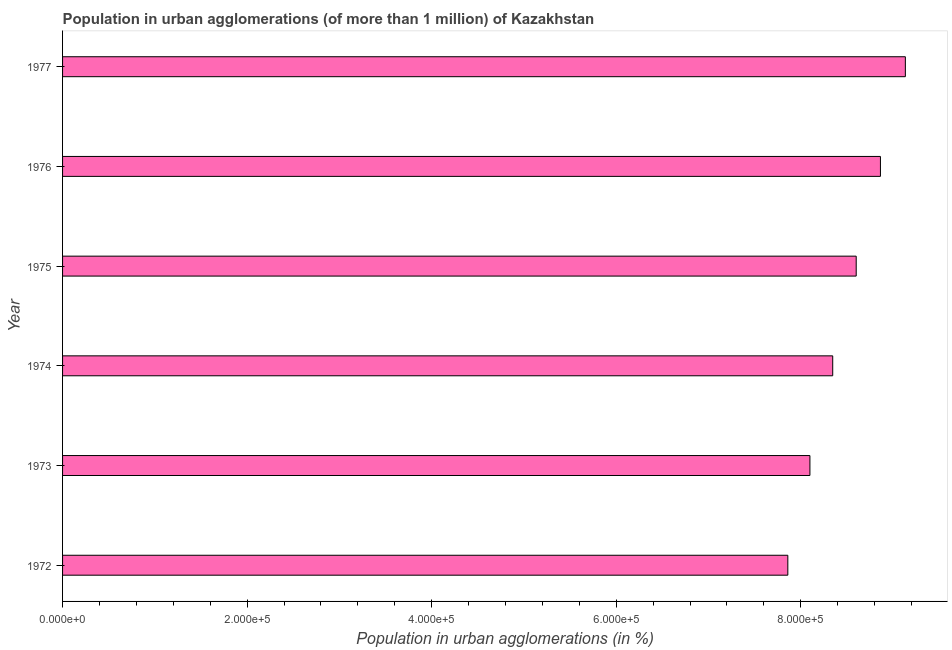Does the graph contain any zero values?
Ensure brevity in your answer.  No. Does the graph contain grids?
Your answer should be compact. No. What is the title of the graph?
Make the answer very short. Population in urban agglomerations (of more than 1 million) of Kazakhstan. What is the label or title of the X-axis?
Keep it short and to the point. Population in urban agglomerations (in %). What is the label or title of the Y-axis?
Offer a terse response. Year. What is the population in urban agglomerations in 1972?
Offer a very short reply. 7.86e+05. Across all years, what is the maximum population in urban agglomerations?
Your answer should be very brief. 9.13e+05. Across all years, what is the minimum population in urban agglomerations?
Ensure brevity in your answer.  7.86e+05. In which year was the population in urban agglomerations maximum?
Provide a succinct answer. 1977. What is the sum of the population in urban agglomerations?
Your answer should be very brief. 5.09e+06. What is the difference between the population in urban agglomerations in 1972 and 1977?
Offer a very short reply. -1.27e+05. What is the average population in urban agglomerations per year?
Your answer should be compact. 8.48e+05. What is the median population in urban agglomerations?
Your answer should be compact. 8.47e+05. In how many years, is the population in urban agglomerations greater than 520000 %?
Give a very brief answer. 6. What is the ratio of the population in urban agglomerations in 1973 to that in 1975?
Keep it short and to the point. 0.94. Is the population in urban agglomerations in 1975 less than that in 1977?
Your answer should be very brief. Yes. Is the difference between the population in urban agglomerations in 1973 and 1976 greater than the difference between any two years?
Your answer should be compact. No. What is the difference between the highest and the second highest population in urban agglomerations?
Make the answer very short. 2.70e+04. What is the difference between the highest and the lowest population in urban agglomerations?
Offer a very short reply. 1.27e+05. Are the values on the major ticks of X-axis written in scientific E-notation?
Keep it short and to the point. Yes. What is the Population in urban agglomerations (in %) of 1972?
Offer a very short reply. 7.86e+05. What is the Population in urban agglomerations (in %) of 1973?
Provide a short and direct response. 8.10e+05. What is the Population in urban agglomerations (in %) of 1974?
Provide a succinct answer. 8.35e+05. What is the Population in urban agglomerations (in %) of 1975?
Give a very brief answer. 8.60e+05. What is the Population in urban agglomerations (in %) in 1976?
Ensure brevity in your answer.  8.86e+05. What is the Population in urban agglomerations (in %) of 1977?
Your response must be concise. 9.13e+05. What is the difference between the Population in urban agglomerations (in %) in 1972 and 1973?
Give a very brief answer. -2.39e+04. What is the difference between the Population in urban agglomerations (in %) in 1972 and 1974?
Your answer should be compact. -4.86e+04. What is the difference between the Population in urban agglomerations (in %) in 1972 and 1975?
Ensure brevity in your answer.  -7.41e+04. What is the difference between the Population in urban agglomerations (in %) in 1972 and 1976?
Offer a very short reply. -1.00e+05. What is the difference between the Population in urban agglomerations (in %) in 1972 and 1977?
Provide a short and direct response. -1.27e+05. What is the difference between the Population in urban agglomerations (in %) in 1973 and 1974?
Provide a succinct answer. -2.47e+04. What is the difference between the Population in urban agglomerations (in %) in 1973 and 1975?
Provide a succinct answer. -5.02e+04. What is the difference between the Population in urban agglomerations (in %) in 1973 and 1976?
Your response must be concise. -7.64e+04. What is the difference between the Population in urban agglomerations (in %) in 1973 and 1977?
Make the answer very short. -1.03e+05. What is the difference between the Population in urban agglomerations (in %) in 1974 and 1975?
Make the answer very short. -2.55e+04. What is the difference between the Population in urban agglomerations (in %) in 1974 and 1976?
Your response must be concise. -5.17e+04. What is the difference between the Population in urban agglomerations (in %) in 1974 and 1977?
Ensure brevity in your answer.  -7.87e+04. What is the difference between the Population in urban agglomerations (in %) in 1975 and 1976?
Your answer should be very brief. -2.63e+04. What is the difference between the Population in urban agglomerations (in %) in 1975 and 1977?
Keep it short and to the point. -5.33e+04. What is the difference between the Population in urban agglomerations (in %) in 1976 and 1977?
Make the answer very short. -2.70e+04. What is the ratio of the Population in urban agglomerations (in %) in 1972 to that in 1973?
Your response must be concise. 0.97. What is the ratio of the Population in urban agglomerations (in %) in 1972 to that in 1974?
Make the answer very short. 0.94. What is the ratio of the Population in urban agglomerations (in %) in 1972 to that in 1975?
Your answer should be very brief. 0.91. What is the ratio of the Population in urban agglomerations (in %) in 1972 to that in 1976?
Keep it short and to the point. 0.89. What is the ratio of the Population in urban agglomerations (in %) in 1972 to that in 1977?
Your response must be concise. 0.86. What is the ratio of the Population in urban agglomerations (in %) in 1973 to that in 1975?
Provide a succinct answer. 0.94. What is the ratio of the Population in urban agglomerations (in %) in 1973 to that in 1976?
Offer a very short reply. 0.91. What is the ratio of the Population in urban agglomerations (in %) in 1973 to that in 1977?
Your response must be concise. 0.89. What is the ratio of the Population in urban agglomerations (in %) in 1974 to that in 1975?
Provide a succinct answer. 0.97. What is the ratio of the Population in urban agglomerations (in %) in 1974 to that in 1976?
Provide a succinct answer. 0.94. What is the ratio of the Population in urban agglomerations (in %) in 1974 to that in 1977?
Provide a short and direct response. 0.91. What is the ratio of the Population in urban agglomerations (in %) in 1975 to that in 1976?
Keep it short and to the point. 0.97. What is the ratio of the Population in urban agglomerations (in %) in 1975 to that in 1977?
Provide a short and direct response. 0.94. What is the ratio of the Population in urban agglomerations (in %) in 1976 to that in 1977?
Make the answer very short. 0.97. 